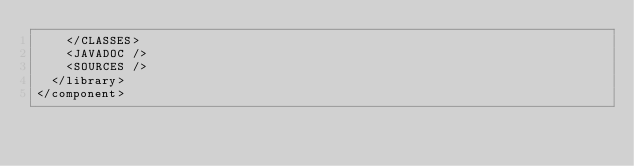Convert code to text. <code><loc_0><loc_0><loc_500><loc_500><_XML_>    </CLASSES>
    <JAVADOC />
    <SOURCES />
  </library>
</component></code> 